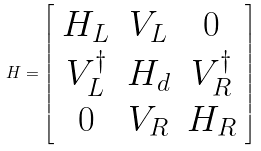Convert formula to latex. <formula><loc_0><loc_0><loc_500><loc_500>H = \left [ \begin{array} { c c c } H _ { L } & V _ { L } & 0 \\ V ^ { \dag } _ { L } & H _ { d } & V ^ { \dag } _ { R } \\ 0 & V _ { R } & H _ { R } \end{array} \right ]</formula> 